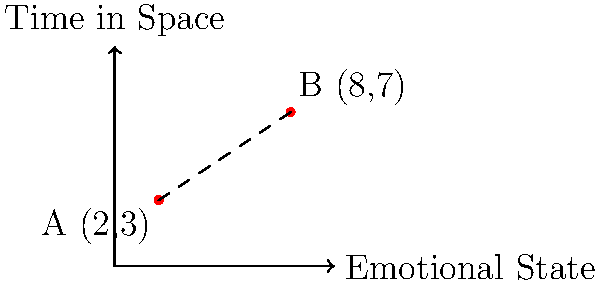On the emotional journey graph of space travelers, point A (2,3) represents the initial state of excitement and anxiety, while point B (8,7) represents a later state of profound reflection and growth. Calculate the emotional distance traveled between these two points on the coordinate plane. Round your answer to two decimal places. To find the distance between two points on a coordinate plane, we can use the distance formula:

$$d = \sqrt{(x_2 - x_1)^2 + (y_2 - y_1)^2}$$

Where $(x_1, y_1)$ are the coordinates of the first point and $(x_2, y_2)$ are the coordinates of the second point.

Given:
Point A: $(2, 3)$
Point B: $(8, 7)$

Let's substitute these values into the formula:

1) $d = \sqrt{(8 - 2)^2 + (7 - 3)^2}$

2) $d = \sqrt{6^2 + 4^2}$

3) $d = \sqrt{36 + 16}$

4) $d = \sqrt{52}$

5) $d \approx 7.21$ (rounded to two decimal places)

Therefore, the emotional distance traveled between the initial state of excitement and anxiety to the later state of profound reflection and growth is approximately 7.21 units on this emotional journey graph.
Answer: 7.21 